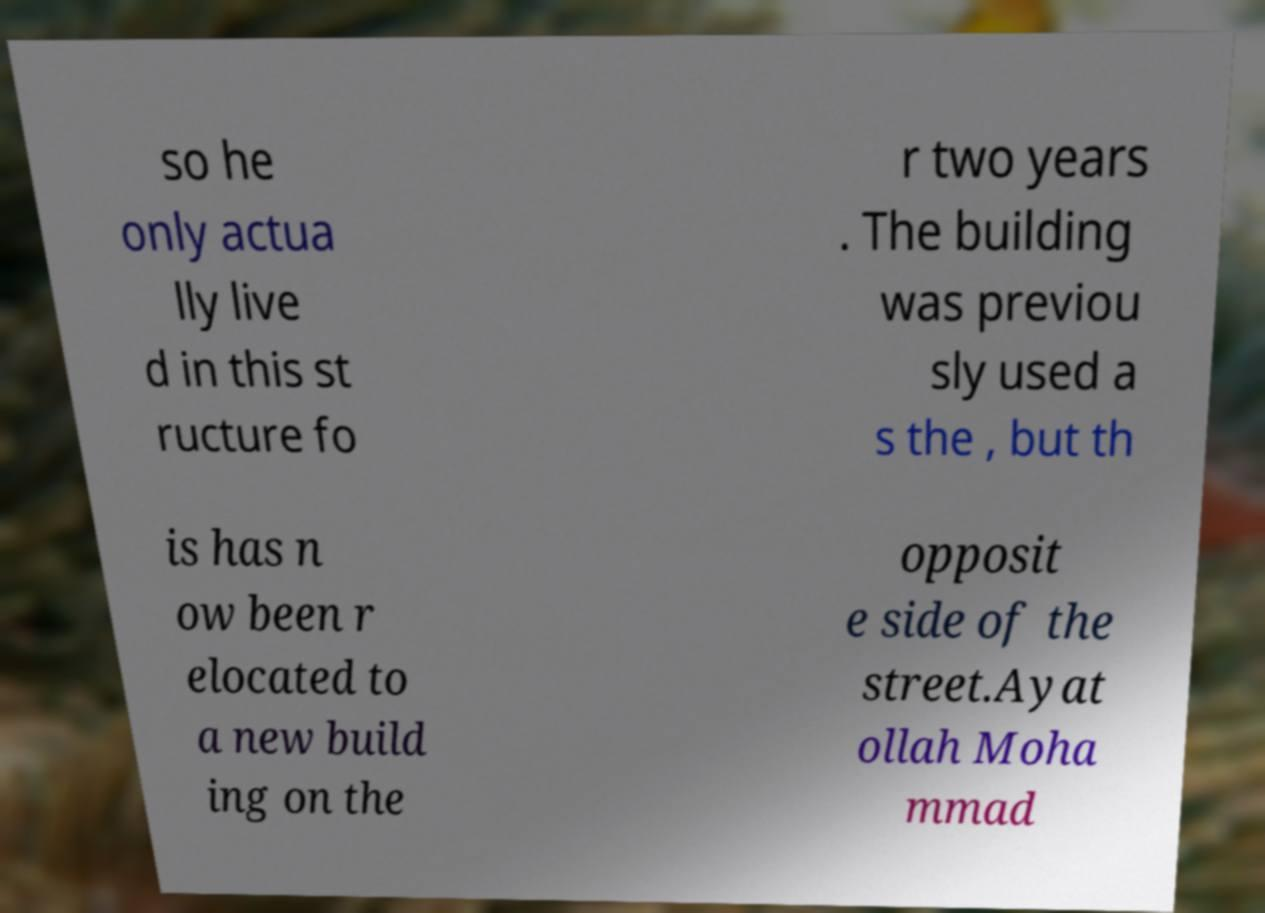Could you assist in decoding the text presented in this image and type it out clearly? so he only actua lly live d in this st ructure fo r two years . The building was previou sly used a s the , but th is has n ow been r elocated to a new build ing on the opposit e side of the street.Ayat ollah Moha mmad 